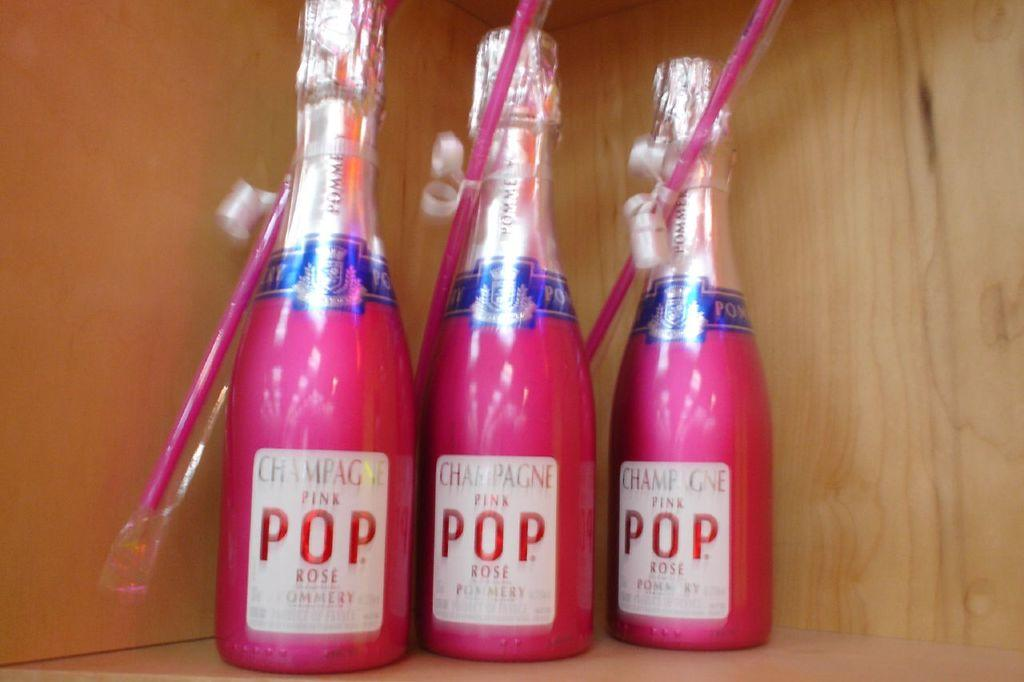How many bottles are visible in the image? There are three bottles in the image. What color are the bottles? The bottles are pink in color. What feature do the bottles have in common? The bottles have straws attached to them. Where are the bottles located? The bottles are on a desk. What type of pie is being served on the desk next to the bottles? There is no pie present in the image; it only features three pink bottles with straws on a desk. 